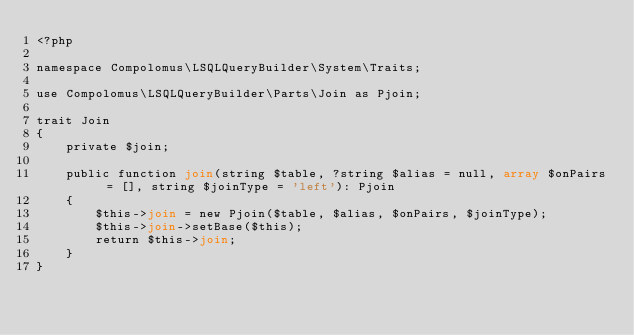<code> <loc_0><loc_0><loc_500><loc_500><_PHP_><?php

namespace Compolomus\LSQLQueryBuilder\System\Traits;

use Compolomus\LSQLQueryBuilder\Parts\Join as Pjoin;

trait Join
{
    private $join;

    public function join(string $table, ?string $alias = null, array $onPairs = [], string $joinType = 'left'): Pjoin
    {
        $this->join = new Pjoin($table, $alias, $onPairs, $joinType);
        $this->join->setBase($this);
        return $this->join;
    }
}
</code> 